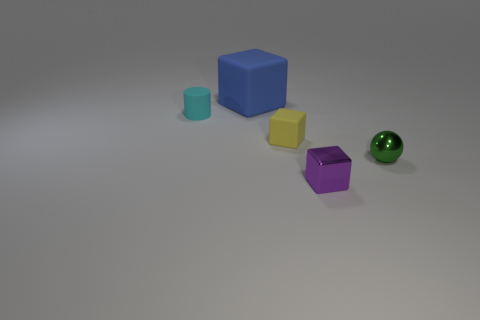Add 4 big brown cylinders. How many objects exist? 9 Subtract all cylinders. How many objects are left? 4 Add 4 large blue cubes. How many large blue cubes exist? 5 Subtract 0 cyan spheres. How many objects are left? 5 Subtract all big red objects. Subtract all tiny shiny balls. How many objects are left? 4 Add 5 small objects. How many small objects are left? 9 